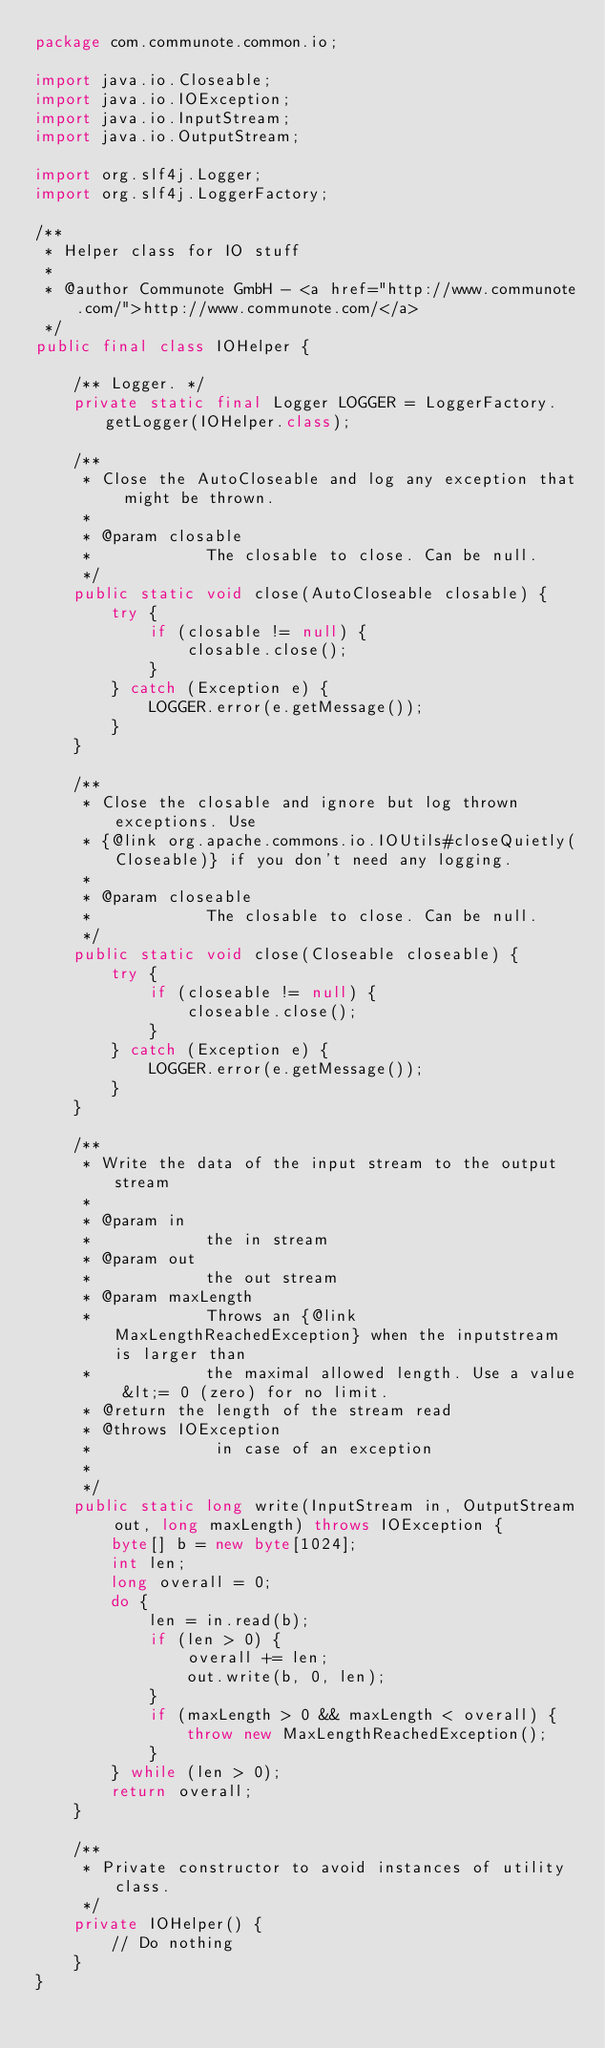Convert code to text. <code><loc_0><loc_0><loc_500><loc_500><_Java_>package com.communote.common.io;

import java.io.Closeable;
import java.io.IOException;
import java.io.InputStream;
import java.io.OutputStream;

import org.slf4j.Logger;
import org.slf4j.LoggerFactory;

/**
 * Helper class for IO stuff
 *
 * @author Communote GmbH - <a href="http://www.communote.com/">http://www.communote.com/</a>
 */
public final class IOHelper {

    /** Logger. */
    private static final Logger LOGGER = LoggerFactory.getLogger(IOHelper.class);

    /**
     * Close the AutoCloseable and log any exception that might be thrown.
     *
     * @param closable
     *            The closable to close. Can be null.
     */
    public static void close(AutoCloseable closable) {
        try {
            if (closable != null) {
                closable.close();
            }
        } catch (Exception e) {
            LOGGER.error(e.getMessage());
        }
    }

    /**
     * Close the closable and ignore but log thrown exceptions. Use
     * {@link org.apache.commons.io.IOUtils#closeQuietly(Closeable)} if you don't need any logging.
     *
     * @param closeable
     *            The closable to close. Can be null.
     */
    public static void close(Closeable closeable) {
        try {
            if (closeable != null) {
                closeable.close();
            }
        } catch (Exception e) {
            LOGGER.error(e.getMessage());
        }
    }

    /**
     * Write the data of the input stream to the output stream
     *
     * @param in
     *            the in stream
     * @param out
     *            the out stream
     * @param maxLength
     *            Throws an {@link MaxLengthReachedException} when the inputstream is larger than
     *            the maximal allowed length. Use a value &lt;= 0 (zero) for no limit.
     * @return the length of the stream read
     * @throws IOException
     *             in case of an exception
     *
     */
    public static long write(InputStream in, OutputStream out, long maxLength) throws IOException {
        byte[] b = new byte[1024];
        int len;
        long overall = 0;
        do {
            len = in.read(b);
            if (len > 0) {
                overall += len;
                out.write(b, 0, len);
            }
            if (maxLength > 0 && maxLength < overall) {
                throw new MaxLengthReachedException();
            }
        } while (len > 0);
        return overall;
    }

    /**
     * Private constructor to avoid instances of utility class.
     */
    private IOHelper() {
        // Do nothing
    }
}
</code> 